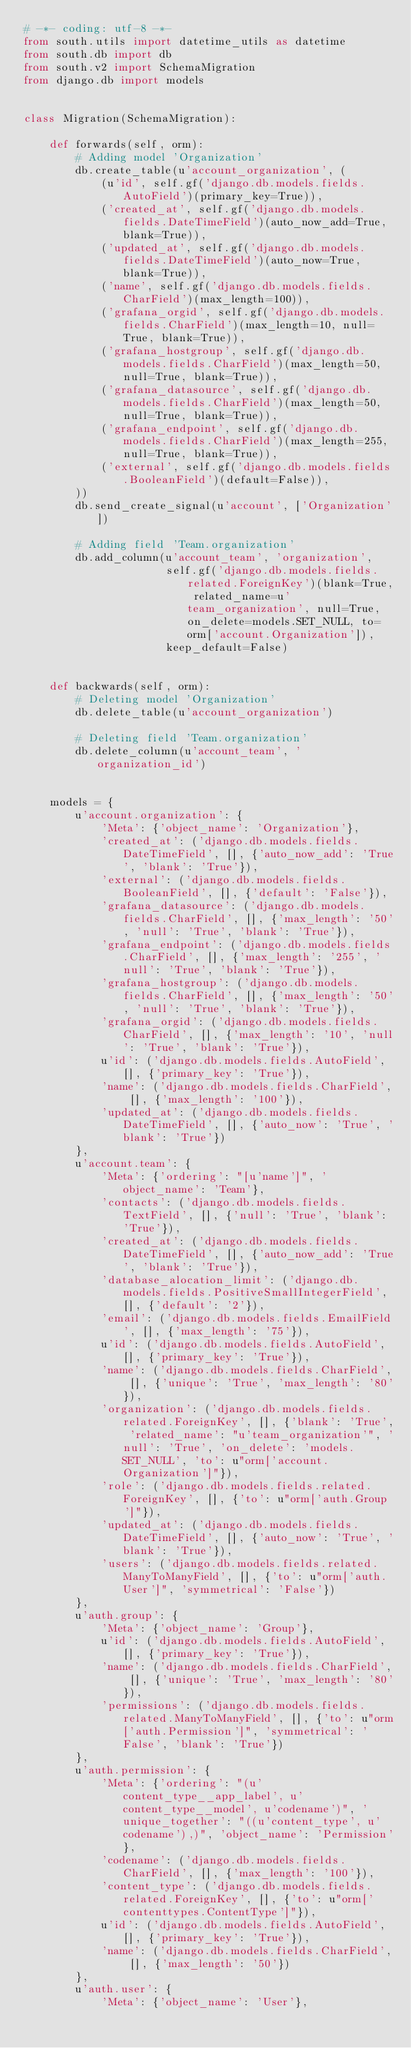<code> <loc_0><loc_0><loc_500><loc_500><_Python_># -*- coding: utf-8 -*-
from south.utils import datetime_utils as datetime
from south.db import db
from south.v2 import SchemaMigration
from django.db import models


class Migration(SchemaMigration):

    def forwards(self, orm):
        # Adding model 'Organization'
        db.create_table(u'account_organization', (
            (u'id', self.gf('django.db.models.fields.AutoField')(primary_key=True)),
            ('created_at', self.gf('django.db.models.fields.DateTimeField')(auto_now_add=True, blank=True)),
            ('updated_at', self.gf('django.db.models.fields.DateTimeField')(auto_now=True, blank=True)),
            ('name', self.gf('django.db.models.fields.CharField')(max_length=100)),
            ('grafana_orgid', self.gf('django.db.models.fields.CharField')(max_length=10, null=True, blank=True)),
            ('grafana_hostgroup', self.gf('django.db.models.fields.CharField')(max_length=50, null=True, blank=True)),
            ('grafana_datasource', self.gf('django.db.models.fields.CharField')(max_length=50, null=True, blank=True)),
            ('grafana_endpoint', self.gf('django.db.models.fields.CharField')(max_length=255, null=True, blank=True)),
            ('external', self.gf('django.db.models.fields.BooleanField')(default=False)),
        ))
        db.send_create_signal(u'account', ['Organization'])

        # Adding field 'Team.organization'
        db.add_column(u'account_team', 'organization',
                      self.gf('django.db.models.fields.related.ForeignKey')(blank=True, related_name=u'team_organization', null=True, on_delete=models.SET_NULL, to=orm['account.Organization']),
                      keep_default=False)


    def backwards(self, orm):
        # Deleting model 'Organization'
        db.delete_table(u'account_organization')

        # Deleting field 'Team.organization'
        db.delete_column(u'account_team', 'organization_id')


    models = {
        u'account.organization': {
            'Meta': {'object_name': 'Organization'},
            'created_at': ('django.db.models.fields.DateTimeField', [], {'auto_now_add': 'True', 'blank': 'True'}),
            'external': ('django.db.models.fields.BooleanField', [], {'default': 'False'}),
            'grafana_datasource': ('django.db.models.fields.CharField', [], {'max_length': '50', 'null': 'True', 'blank': 'True'}),
            'grafana_endpoint': ('django.db.models.fields.CharField', [], {'max_length': '255', 'null': 'True', 'blank': 'True'}),
            'grafana_hostgroup': ('django.db.models.fields.CharField', [], {'max_length': '50', 'null': 'True', 'blank': 'True'}),
            'grafana_orgid': ('django.db.models.fields.CharField', [], {'max_length': '10', 'null': 'True', 'blank': 'True'}),
            u'id': ('django.db.models.fields.AutoField', [], {'primary_key': 'True'}),
            'name': ('django.db.models.fields.CharField', [], {'max_length': '100'}),
            'updated_at': ('django.db.models.fields.DateTimeField', [], {'auto_now': 'True', 'blank': 'True'})
        },
        u'account.team': {
            'Meta': {'ordering': "[u'name']", 'object_name': 'Team'},
            'contacts': ('django.db.models.fields.TextField', [], {'null': 'True', 'blank': 'True'}),
            'created_at': ('django.db.models.fields.DateTimeField', [], {'auto_now_add': 'True', 'blank': 'True'}),
            'database_alocation_limit': ('django.db.models.fields.PositiveSmallIntegerField', [], {'default': '2'}),
            'email': ('django.db.models.fields.EmailField', [], {'max_length': '75'}),
            u'id': ('django.db.models.fields.AutoField', [], {'primary_key': 'True'}),
            'name': ('django.db.models.fields.CharField', [], {'unique': 'True', 'max_length': '80'}),
            'organization': ('django.db.models.fields.related.ForeignKey', [], {'blank': 'True', 'related_name': "u'team_organization'", 'null': 'True', 'on_delete': 'models.SET_NULL', 'to': u"orm['account.Organization']"}),
            'role': ('django.db.models.fields.related.ForeignKey', [], {'to': u"orm['auth.Group']"}),
            'updated_at': ('django.db.models.fields.DateTimeField', [], {'auto_now': 'True', 'blank': 'True'}),
            'users': ('django.db.models.fields.related.ManyToManyField', [], {'to': u"orm['auth.User']", 'symmetrical': 'False'})
        },
        u'auth.group': {
            'Meta': {'object_name': 'Group'},
            u'id': ('django.db.models.fields.AutoField', [], {'primary_key': 'True'}),
            'name': ('django.db.models.fields.CharField', [], {'unique': 'True', 'max_length': '80'}),
            'permissions': ('django.db.models.fields.related.ManyToManyField', [], {'to': u"orm['auth.Permission']", 'symmetrical': 'False', 'blank': 'True'})
        },
        u'auth.permission': {
            'Meta': {'ordering': "(u'content_type__app_label', u'content_type__model', u'codename')", 'unique_together': "((u'content_type', u'codename'),)", 'object_name': 'Permission'},
            'codename': ('django.db.models.fields.CharField', [], {'max_length': '100'}),
            'content_type': ('django.db.models.fields.related.ForeignKey', [], {'to': u"orm['contenttypes.ContentType']"}),
            u'id': ('django.db.models.fields.AutoField', [], {'primary_key': 'True'}),
            'name': ('django.db.models.fields.CharField', [], {'max_length': '50'})
        },
        u'auth.user': {
            'Meta': {'object_name': 'User'},</code> 